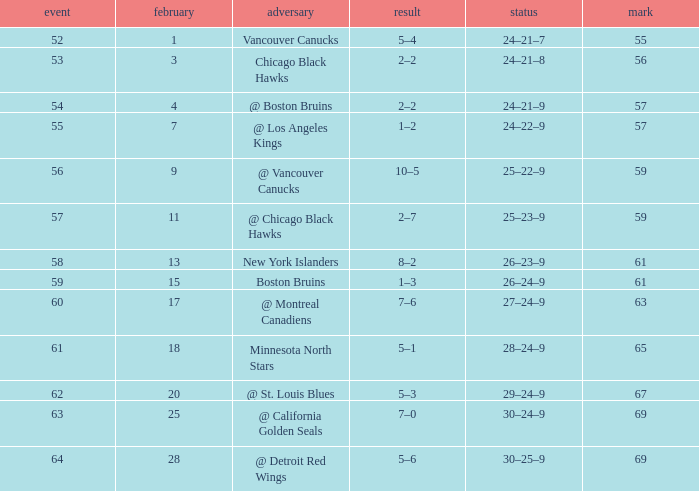Which opponent has a game larger than 61, february smaller than 28, and fewer points than 69? @ St. Louis Blues. 